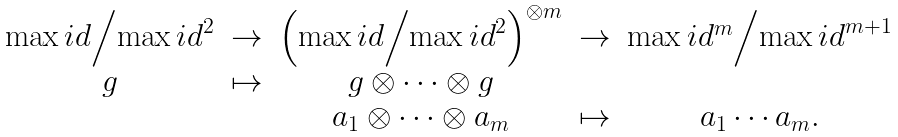<formula> <loc_0><loc_0><loc_500><loc_500>\begin{matrix} \max i d \Big / { \max i d } ^ { 2 } & \rightarrow & \left ( \max i d \Big / { \max i d } ^ { 2 } \right ) ^ { \otimes m } & \rightarrow & \max i d ^ { m } \Big / { \max i d } ^ { m + 1 } \\ g & \mapsto & g \otimes \cdots \otimes g & & \\ & & a _ { 1 } \otimes \cdots \otimes a _ { m } & \mapsto & a _ { 1 } \cdots a _ { m } . \end{matrix}</formula> 